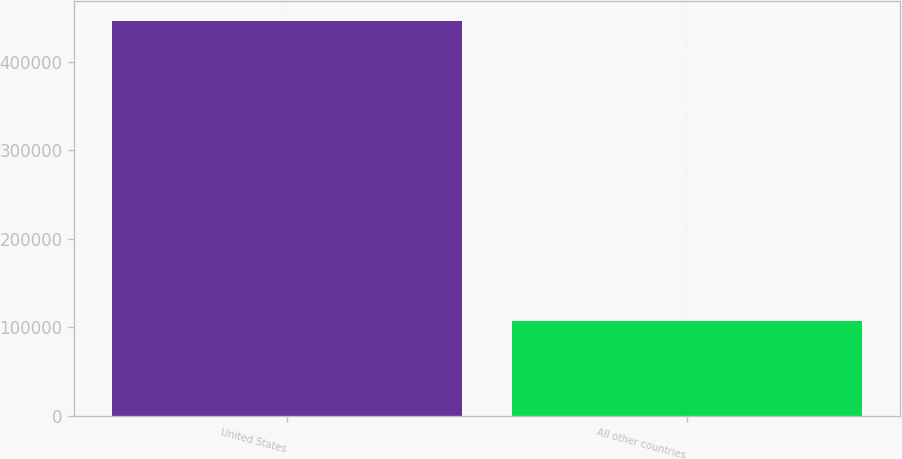Convert chart. <chart><loc_0><loc_0><loc_500><loc_500><bar_chart><fcel>United States<fcel>All other countries<nl><fcel>446044<fcel>107082<nl></chart> 